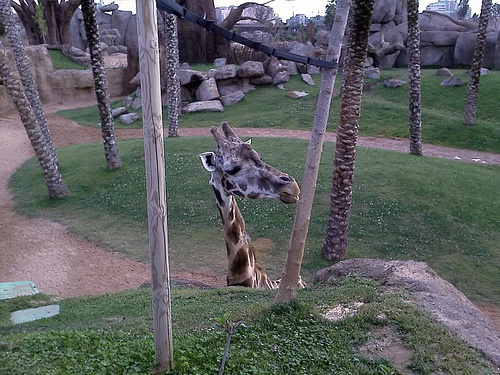Describe the objects in this image and their specific colors. I can see a giraffe in darkgray, gray, and black tones in this image. 